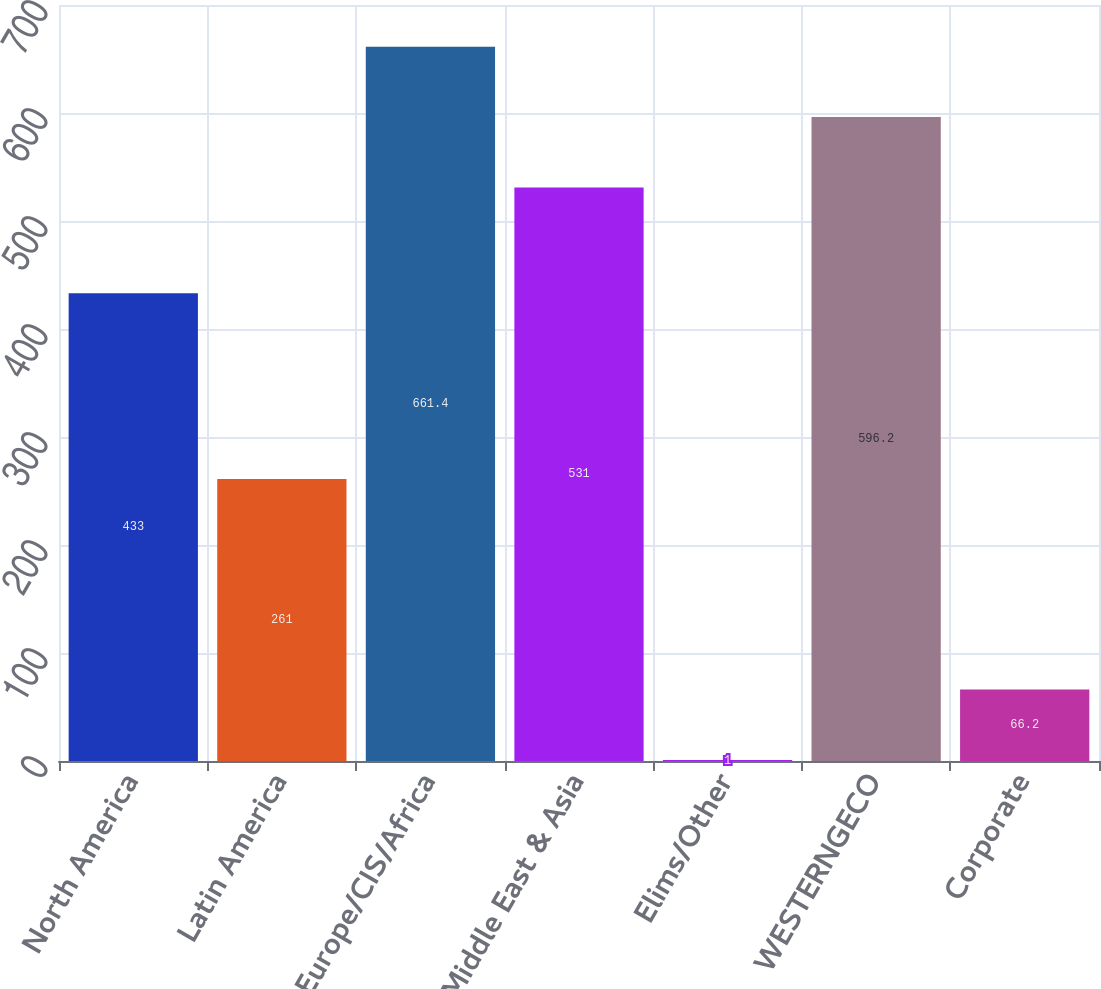<chart> <loc_0><loc_0><loc_500><loc_500><bar_chart><fcel>North America<fcel>Latin America<fcel>Europe/CIS/Africa<fcel>Middle East & Asia<fcel>Elims/Other<fcel>WESTERNGECO<fcel>Corporate<nl><fcel>433<fcel>261<fcel>661.4<fcel>531<fcel>1<fcel>596.2<fcel>66.2<nl></chart> 